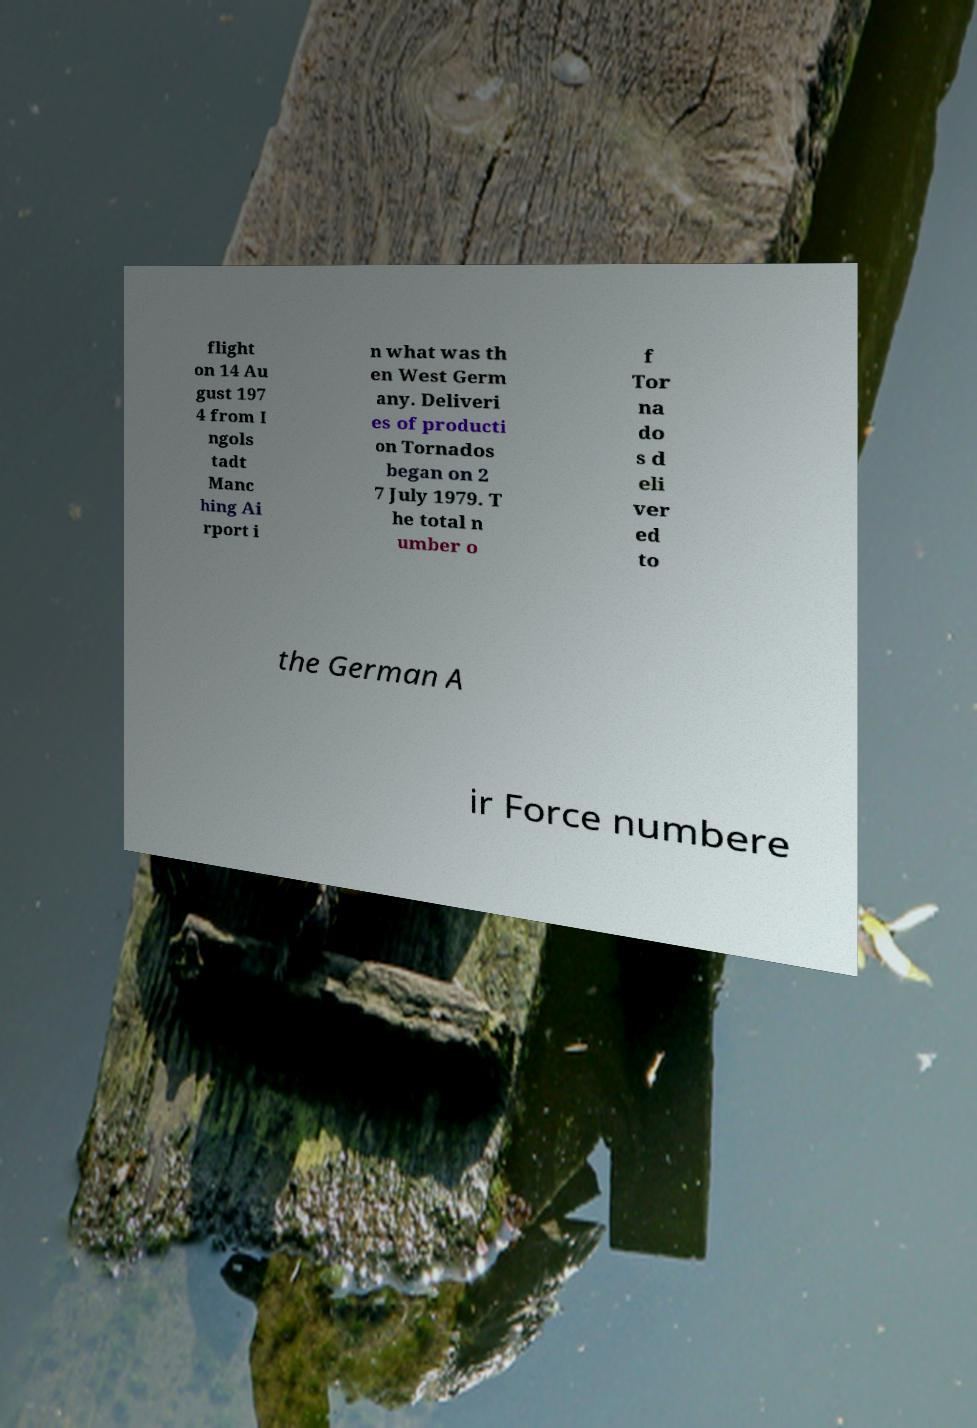Could you assist in decoding the text presented in this image and type it out clearly? flight on 14 Au gust 197 4 from I ngols tadt Manc hing Ai rport i n what was th en West Germ any. Deliveri es of producti on Tornados began on 2 7 July 1979. T he total n umber o f Tor na do s d eli ver ed to the German A ir Force numbere 